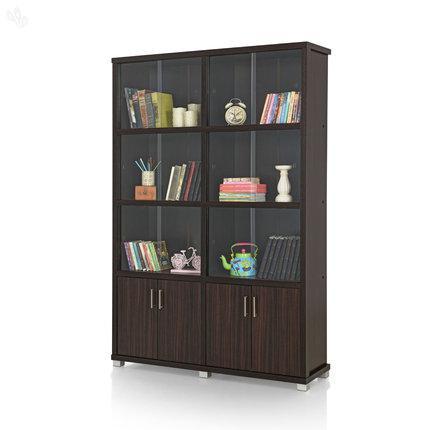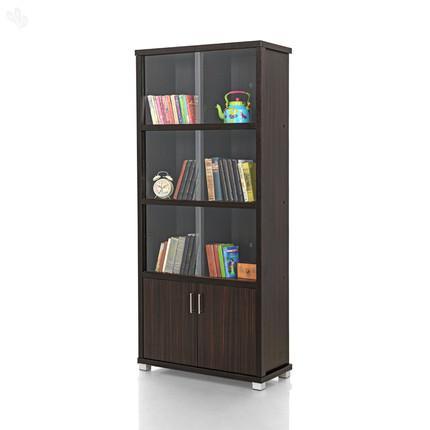The first image is the image on the left, the second image is the image on the right. For the images shown, is this caption "There is a white pail shaped vase on a shelf." true? Answer yes or no. No. 